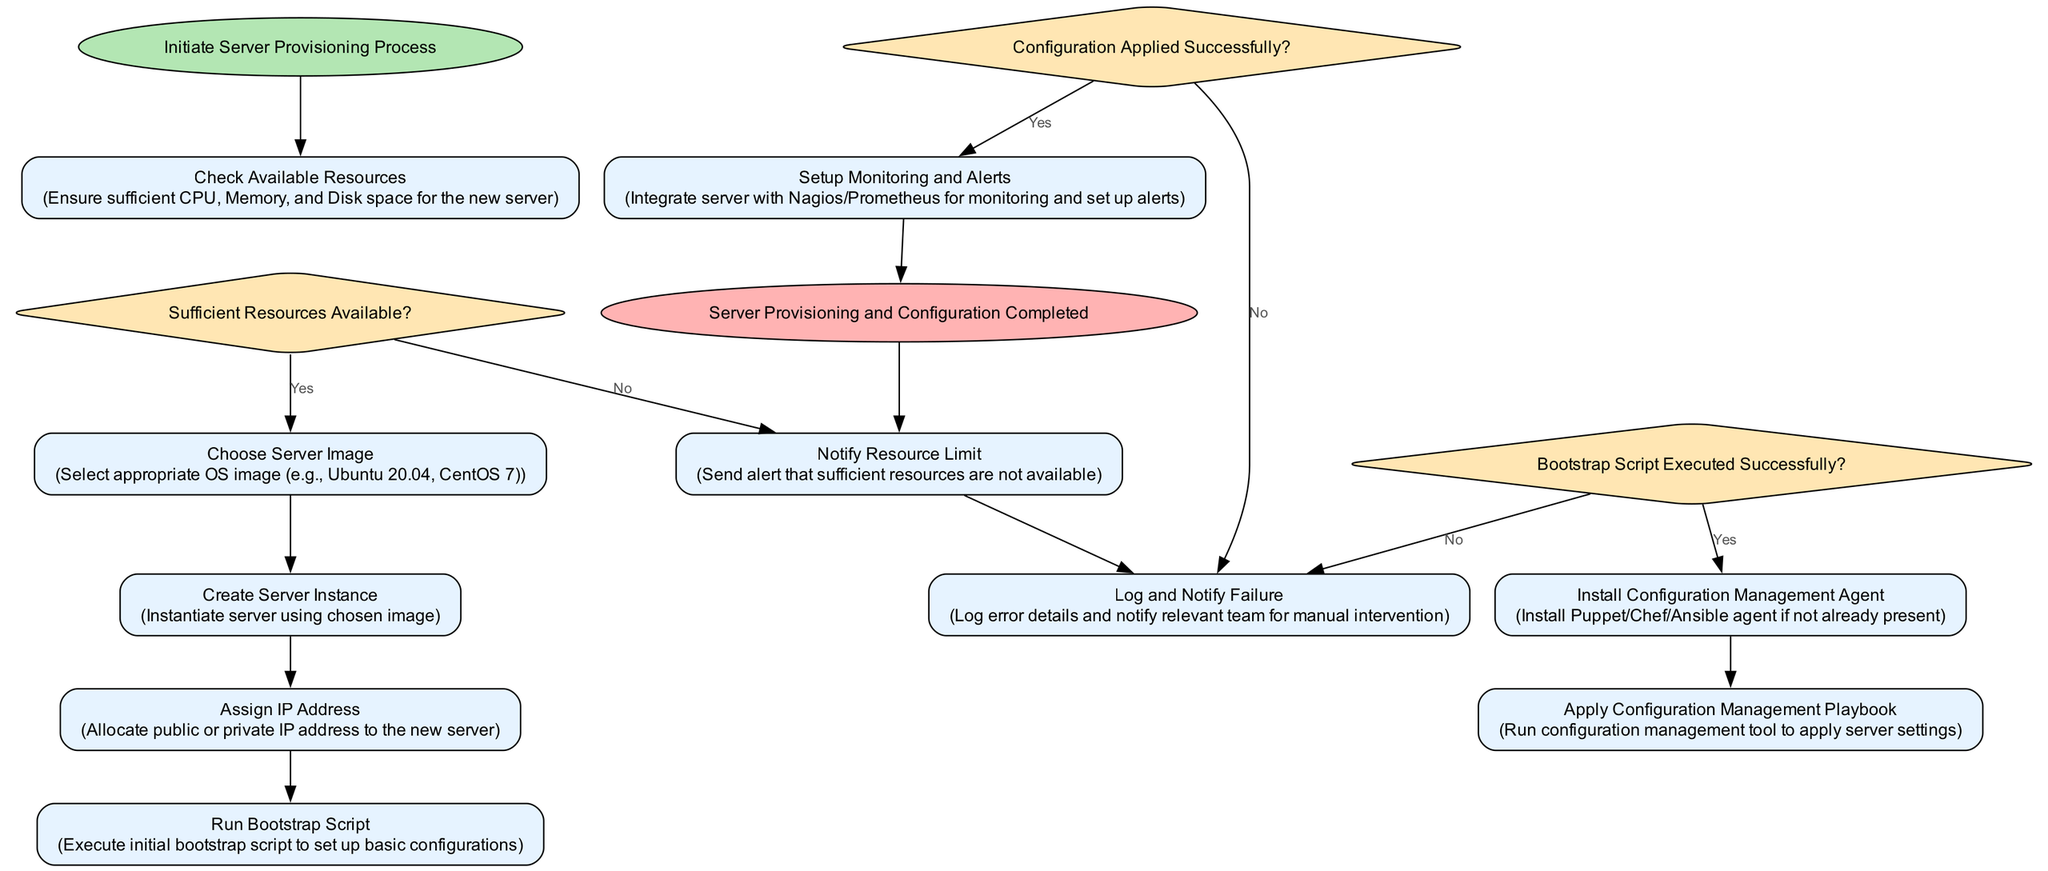What is the first action in the flowchart? The first action is "Check Available Resources," which is indicated as the second element in the flowchart after the Start node.
Answer: Check Available Resources What happens if there are insufficient resources available? If resources are insufficient, the flowchart indicates that the next step is to "Notify Resource Limit," which branches from the "Sufficient Resources Available?" decision node.
Answer: Notify Resource Limit How many actions are performed after choosing the server image? After choosing the server image, there are three actions performed consecutively: "Create Server Instance," "Assign IP Address," and "Run Bootstrap Script."
Answer: Three What is the final outcome of the processing described in the flowchart? The final outcome described in the flowchart is "Server Provisioning and Configuration Completed," which is at the end of the flowchart.
Answer: Server Provisioning and Configuration Completed What decision must be made after running the bootstrap script? After running the bootstrap script, the decision that must be made is "Bootstrap Script Executed Successfully?" which determines the next action based on its success or failure.
Answer: Bootstrap Script Executed Successfully? What action follows a successful configuration application? A successful configuration application leads to the action "Setup Monitoring and Alerts," as indicated after the decision node for configuration success.
Answer: Setup Monitoring and Alerts How many decision nodes are present in the flowchart? There are three decision nodes in the flowchart: one for checking resource availability, one for bootstrap script execution success, and one for configuration application success.
Answer: Three What action is taken if the bootstrap script execution fails? If the bootstrap script execution fails, the flowchart specifies "Log and Notify Failure" as the next action.
Answer: Log and Notify Failure What type of node is used for the "Sufficient Resources Available?" step? The node for "Sufficient Resources Available?" is a decision node, as indicated by its shape being a diamond.
Answer: Decision node 